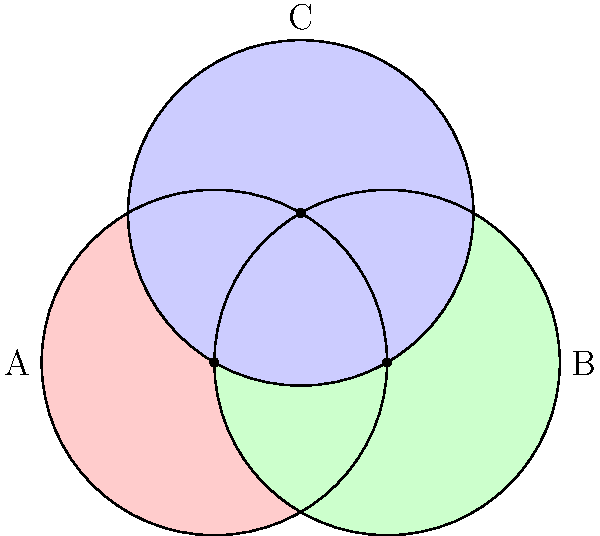In your latest DIY renovation project, you want to create an optical illusion using non-Euclidean geometry principles. You decide to paint three overlapping circles on a wall, as shown in the diagram. If the radius of each circle is 1 unit, what is the area of the region where all three circles overlap (the central region)? To find the area of the central region where all three circles overlap, we need to follow these steps:

1) First, recognize that the centers of the circles form an equilateral triangle with side length 1.

2) The area we're looking for is the difference between the area of one circle and the areas of three equal circular segments.

3) The area of one circle is $A_c = \pi r^2 = \pi$ (since r = 1).

4) To find the area of one circular segment, we need to:
   a) Calculate the central angle $\theta$ of the segment
   b) Calculate the area of the sector
   c) Subtract the area of the equilateral triangle

5) The central angle $\theta$ can be found using the formula:
   $\cos(\theta/2) = 1/2$
   $\theta = 2 \arccos(1/2) = 2\pi/3$

6) The area of the sector is:
   $A_s = \frac{\theta}{2\pi} \pi r^2 = \frac{2\pi/3}{2\pi} \pi = \frac{\pi}{3}$

7) The area of the equilateral triangle is:
   $A_t = \frac{\sqrt{3}}{4}$

8) The area of one circular segment is:
   $A_{seg} = A_s - A_t = \frac{\pi}{3} - \frac{\sqrt{3}}{4}$

9) The area of the central region is:
   $A_{central} = A_c - 3A_{seg} = \pi - 3(\frac{\pi}{3} - \frac{\sqrt{3}}{4}) = \frac{3\sqrt{3}}{4} - \frac{\pi}{3}$

Therefore, the area of the central region is $\frac{3\sqrt{3}}{4} - \frac{\pi}{3}$ square units.
Answer: $\frac{3\sqrt{3}}{4} - \frac{\pi}{3}$ square units 